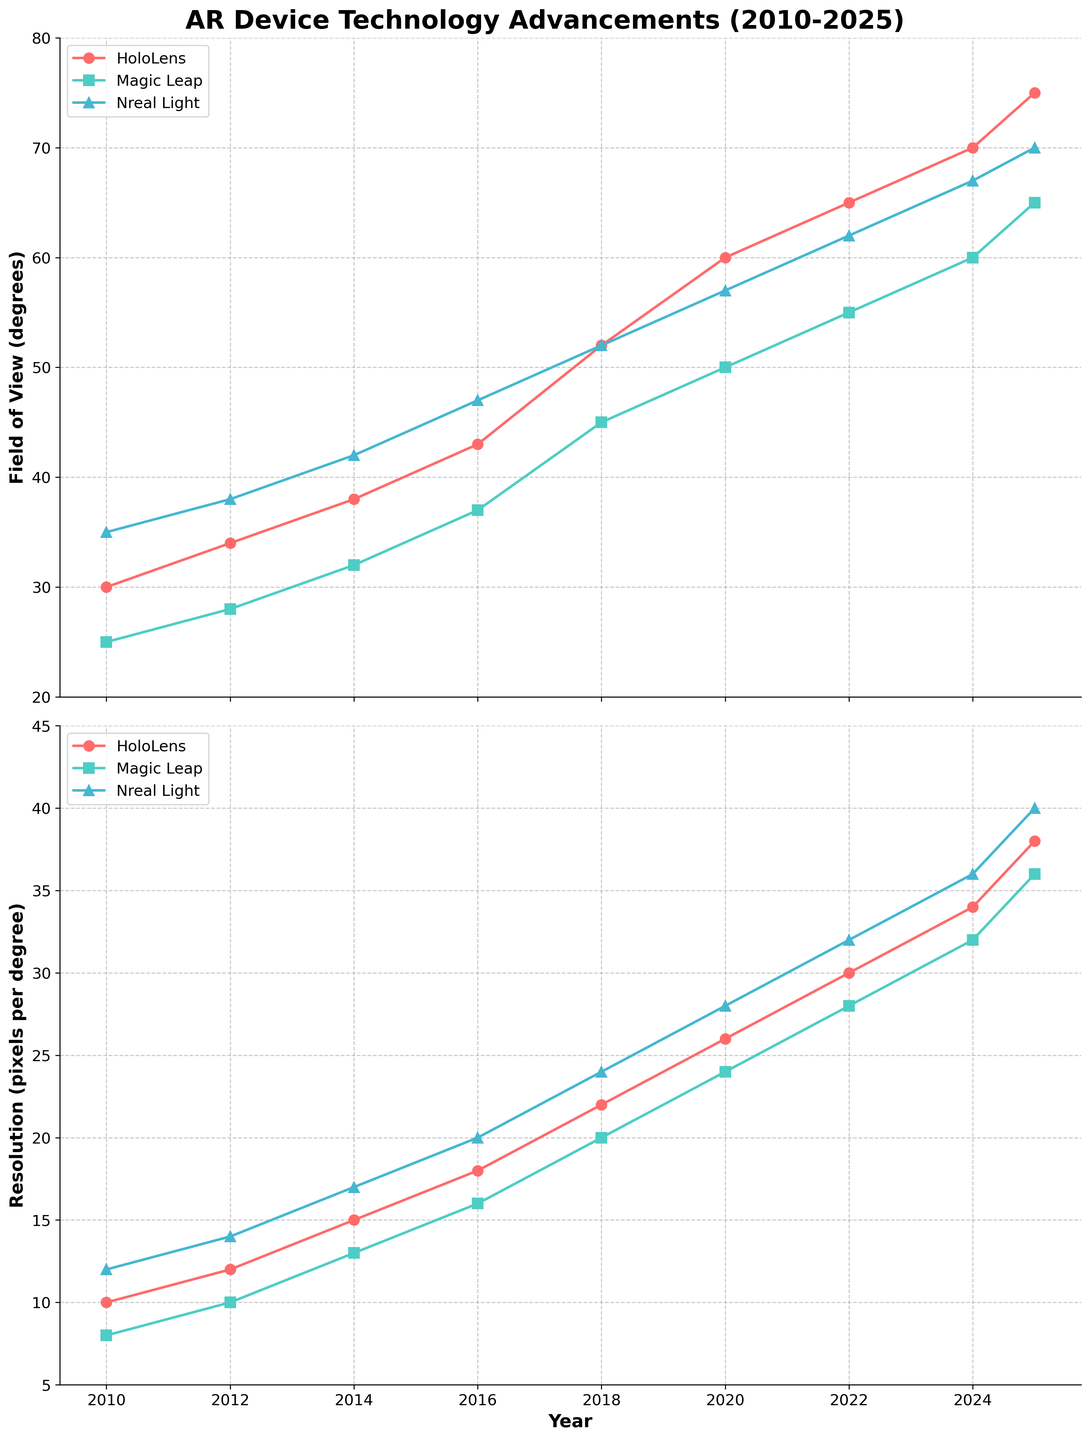What is the trend in the field of view for HoloLens from 2010 to 2025? By looking at the visual progression of the red line representing HoloLens FOV in the top plot, we can see it increases consistently from 30 degrees in 2010 to 75 degrees in 2025.
Answer: Increasing Which device had the highest resolution in 2020? Comparing the height of the three lines in the bottom plot at the 2020 mark, HoloLens has the highest value, depicted by the tallest red line, at 26 pixels per degree.
Answer: HoloLens By how many degrees did Magic Leap's field of view increase between 2012 and 2018? The Magic Leap FOV in 2012 is 28 degrees and in 2018 is 45 degrees. The difference is 45 - 28 = 17 degrees.
Answer: 17 degrees Which device demonstrated the highest improvement in field of view from 2012 to 2016? Calculating the difference for each device between 2012 and 2016: 
- HoloLens: 43 - 34 = 9 degrees 
- Magic Leap: 37 - 28 = 9 degrees 
- Nreal Light: 47 - 38 = 9 degrees
All devices show the same improvement (9 degrees).
Answer: Equal improvement (9 degrees) In 2022, how are the resolutions of Magic Leap and Nreal Light compared? Observing the 2022 data point in the bottom plot for both devices, the Magic Leap resolution is 28 pixels per degree while the Nreal Light resolution is 32 pixels per degree. Thus, Nreal Light has a higher resolution.
Answer: Nreal Light has a higher resolution What was the average field of view for HoloLens over the years presented? Sum the FOV values for HoloLens from 2010 to 2025: (30 + 34 + 38 + 43 + 52 + 60 + 65 + 70 + 75) = 467 degrees. There are 9 years, hence the average is 467/9 = 51.9 degrees.
Answer: 51.9 degrees Which device had the least improvement in resolution from 2014 to 2020? Calculating the improvement in resolution for each device from 2014 to 2020:
- HoloLens: 26 - 15 = 11 pixels per degree
- Magic Leap: 24 - 13 = 11 pixels per degree
- Nreal Light: 28 - 17 = 11 pixels per degree
All devices show the same improvement (11 pixels per degree).
Answer: Equal improvement (11 pixels per degree) How much higher is the field of view of Nreal Light compared to Magic Leap in 2025? Checking the values at the 2025 data point in the top plot for both devices, Nreal Light is at 70 degrees and Magic Leap is at 65 degrees. The difference is 70 - 65 = 5 degrees.
Answer: 5 degrees If the trend continues, what is the estimated field of view for HoloLens in 2026? The HoloLens FOV increased by an average rate of (75 - 70) / (2025 - 2024) = 5 degrees per year from 2024 to 2025. Adding this to the 2025 value, the estimated FOV in 2026 would be 75 + 5 = 80 degrees.
Answer: 80 degrees 